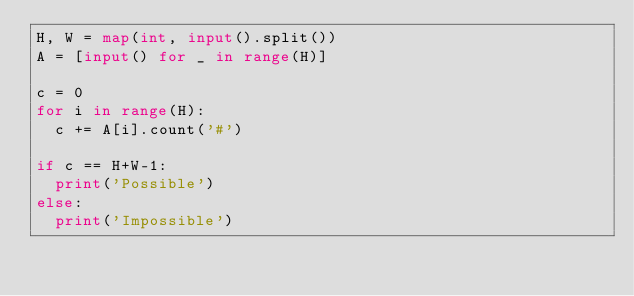Convert code to text. <code><loc_0><loc_0><loc_500><loc_500><_Python_>H, W = map(int, input().split())
A = [input() for _ in range(H)]

c = 0
for i in range(H):
  c += A[i].count('#')

if c == H+W-1:
  print('Possible')
else:
  print('Impossible')
</code> 